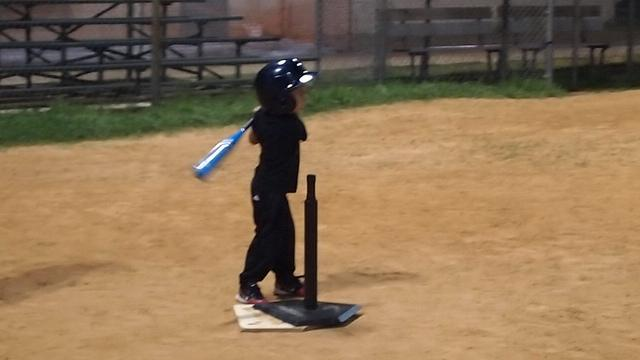Who would the child be more likely to admire? Please explain your reasoning. pete alonso. The child likes baseball players. 